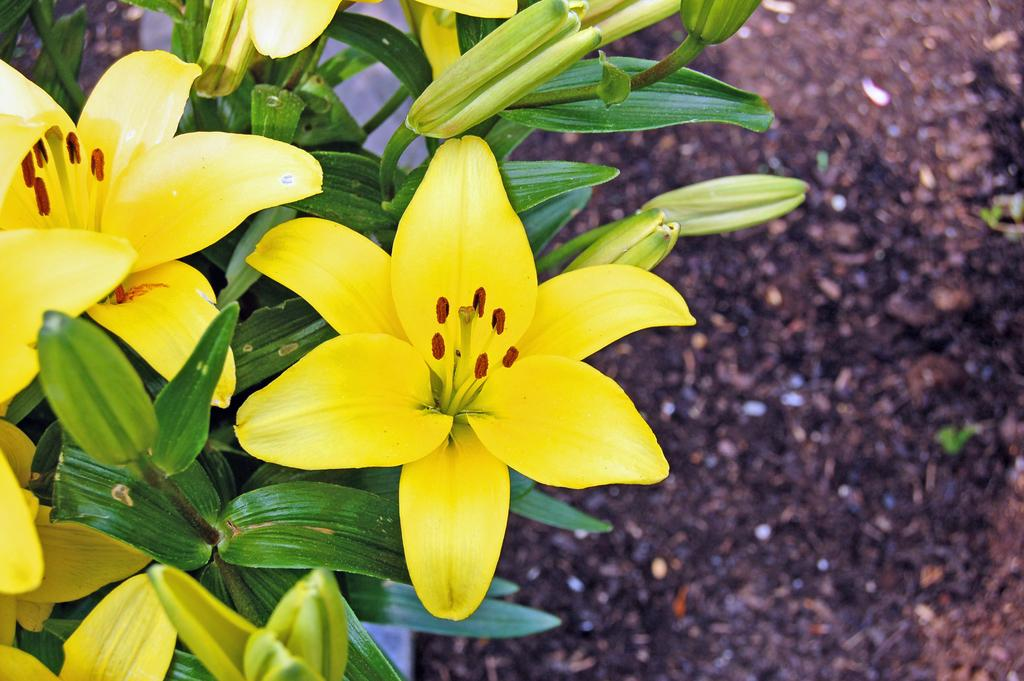What type of flowers can be seen in the foreground of the image? There are yellow colored flowers in the foreground of the image. What are the flowers growing on? The flowers are on plants. What can be seen in the background of the image? There is ground visible in the background of the image. What type of desk can be seen in the image? There is no desk present in the image; it features yellow colored flowers in the foreground and ground in the background. 